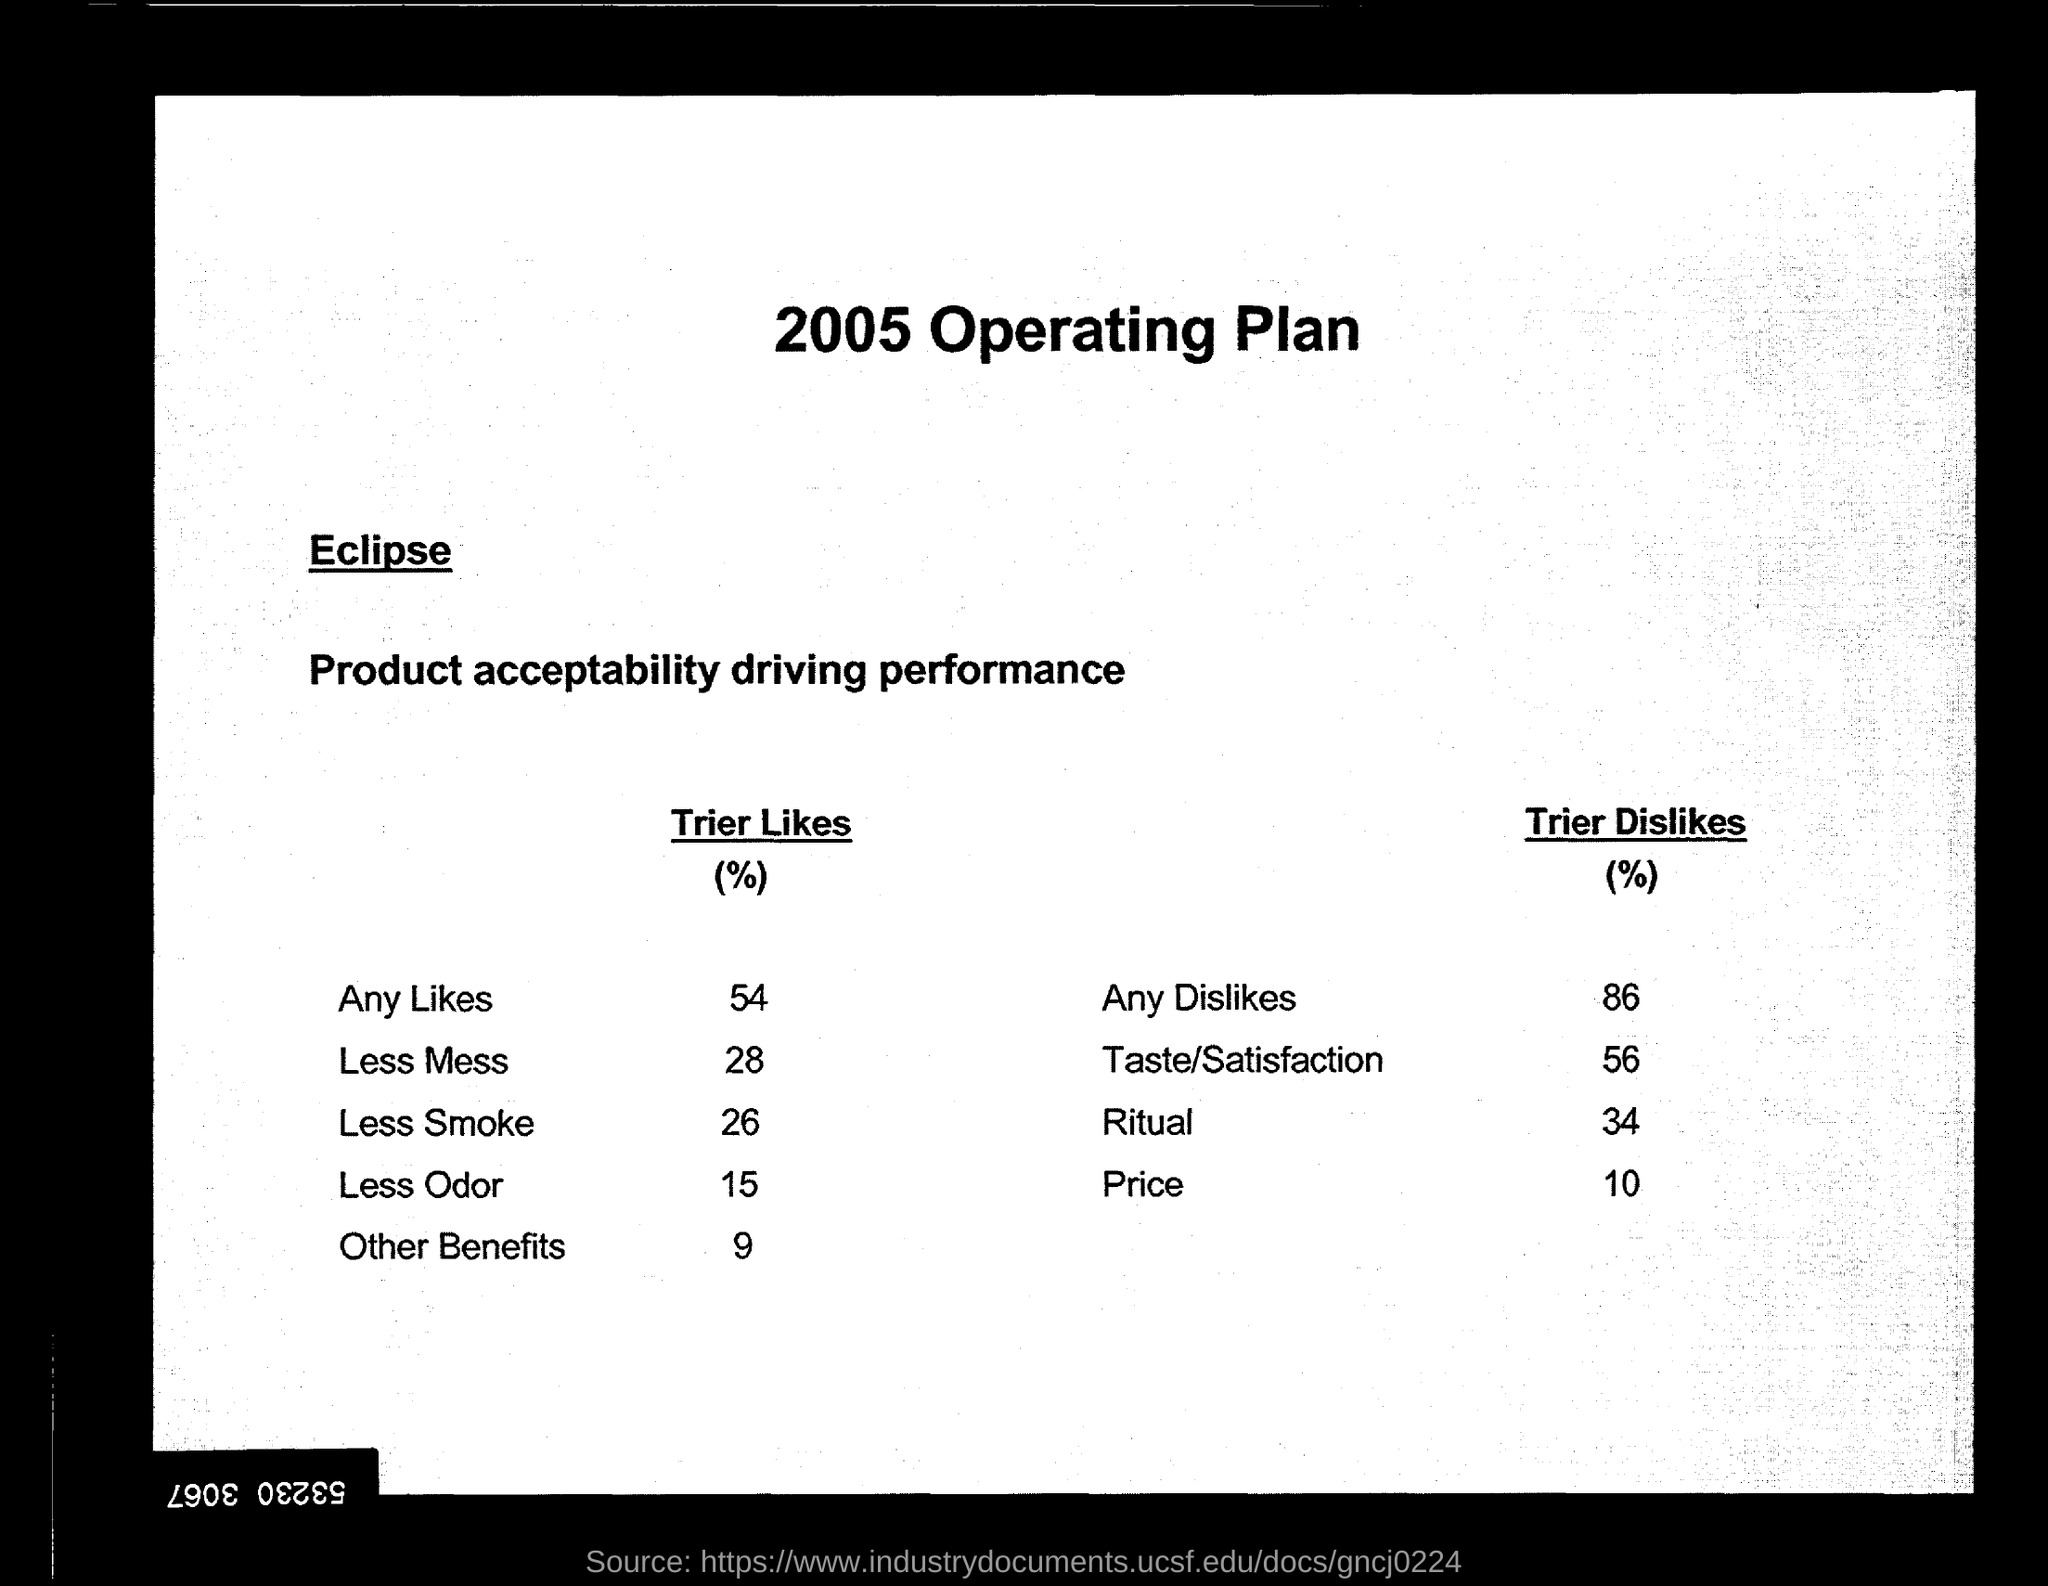Highlight a few significant elements in this photo. The Trier Likes percentage for the "Less Smoke" option is 26%. The Trier DisLikes percentage for the game "Ritual" is 34%. The Trier Likes test results for "Less Odor" are: 15% of the people who tested the product liked it. The Trier Likes percentage for the product "Less Mess" is 28. 